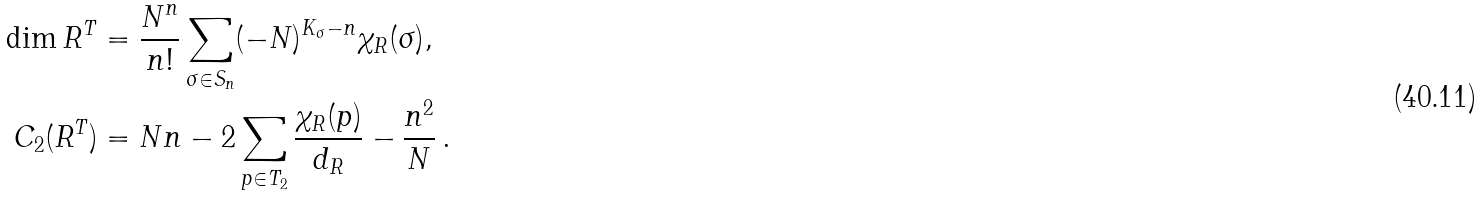Convert formula to latex. <formula><loc_0><loc_0><loc_500><loc_500>\dim R ^ { T } & = \frac { N ^ { n } } { n ! } \sum _ { \sigma \in S _ { n } } ( - N ) ^ { K _ { \sigma } - n } \chi _ { R } ( \sigma ) , \\ C _ { 2 } ( R ^ { T } ) & = N n - 2 \sum _ { p \in T _ { 2 } } \frac { \chi _ { R } ( p ) } { d _ { R } } - \frac { n ^ { 2 } } { N } \, .</formula> 